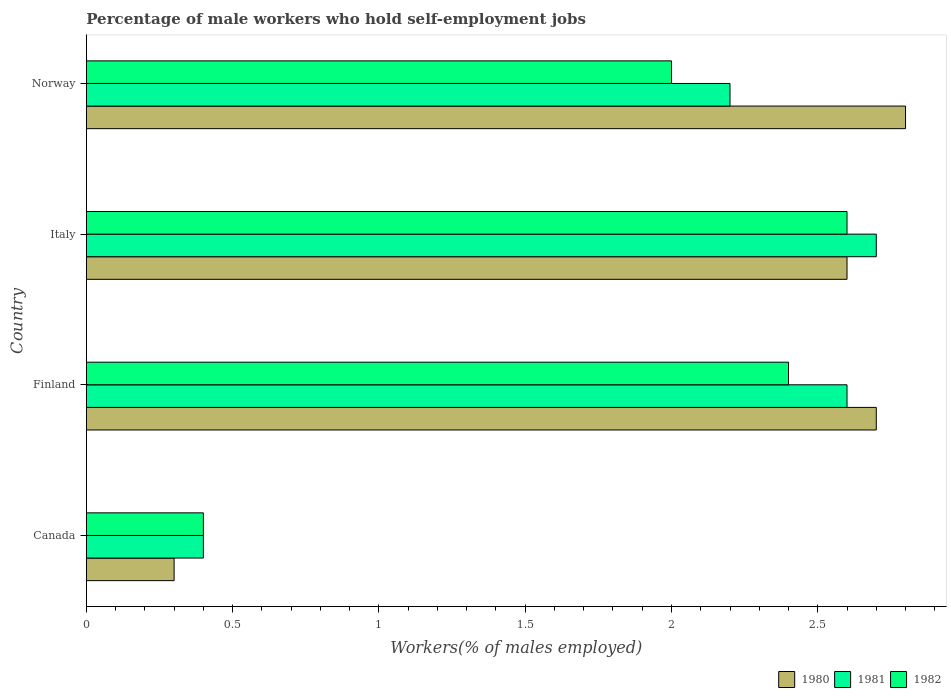Are the number of bars per tick equal to the number of legend labels?
Keep it short and to the point. Yes. Are the number of bars on each tick of the Y-axis equal?
Your answer should be compact. Yes. What is the percentage of self-employed male workers in 1981 in Italy?
Keep it short and to the point. 2.7. Across all countries, what is the maximum percentage of self-employed male workers in 1981?
Offer a very short reply. 2.7. Across all countries, what is the minimum percentage of self-employed male workers in 1982?
Give a very brief answer. 0.4. What is the total percentage of self-employed male workers in 1981 in the graph?
Keep it short and to the point. 7.9. What is the difference between the percentage of self-employed male workers in 1980 in Canada and that in Italy?
Your response must be concise. -2.3. What is the difference between the percentage of self-employed male workers in 1980 in Canada and the percentage of self-employed male workers in 1981 in Finland?
Make the answer very short. -2.3. What is the average percentage of self-employed male workers in 1982 per country?
Ensure brevity in your answer.  1.85. What is the difference between the percentage of self-employed male workers in 1981 and percentage of self-employed male workers in 1982 in Finland?
Offer a very short reply. 0.2. In how many countries, is the percentage of self-employed male workers in 1980 greater than 1.4 %?
Offer a terse response. 3. What is the ratio of the percentage of self-employed male workers in 1982 in Canada to that in Norway?
Provide a succinct answer. 0.2. Is the percentage of self-employed male workers in 1981 in Italy less than that in Norway?
Keep it short and to the point. No. Is the difference between the percentage of self-employed male workers in 1981 in Finland and Italy greater than the difference between the percentage of self-employed male workers in 1982 in Finland and Italy?
Offer a terse response. Yes. What is the difference between the highest and the second highest percentage of self-employed male workers in 1982?
Make the answer very short. 0.2. What is the difference between the highest and the lowest percentage of self-employed male workers in 1982?
Make the answer very short. 2.2. In how many countries, is the percentage of self-employed male workers in 1982 greater than the average percentage of self-employed male workers in 1982 taken over all countries?
Offer a very short reply. 3. What does the 1st bar from the top in Norway represents?
Provide a short and direct response. 1982. What does the 2nd bar from the bottom in Norway represents?
Your answer should be compact. 1981. Is it the case that in every country, the sum of the percentage of self-employed male workers in 1980 and percentage of self-employed male workers in 1982 is greater than the percentage of self-employed male workers in 1981?
Make the answer very short. Yes. How many countries are there in the graph?
Your response must be concise. 4. Does the graph contain grids?
Your answer should be very brief. No. Where does the legend appear in the graph?
Offer a terse response. Bottom right. How many legend labels are there?
Offer a very short reply. 3. What is the title of the graph?
Your answer should be compact. Percentage of male workers who hold self-employment jobs. Does "1993" appear as one of the legend labels in the graph?
Provide a succinct answer. No. What is the label or title of the X-axis?
Your response must be concise. Workers(% of males employed). What is the Workers(% of males employed) in 1980 in Canada?
Your response must be concise. 0.3. What is the Workers(% of males employed) in 1981 in Canada?
Make the answer very short. 0.4. What is the Workers(% of males employed) in 1982 in Canada?
Give a very brief answer. 0.4. What is the Workers(% of males employed) of 1980 in Finland?
Give a very brief answer. 2.7. What is the Workers(% of males employed) of 1981 in Finland?
Ensure brevity in your answer.  2.6. What is the Workers(% of males employed) of 1982 in Finland?
Your answer should be very brief. 2.4. What is the Workers(% of males employed) in 1980 in Italy?
Give a very brief answer. 2.6. What is the Workers(% of males employed) in 1981 in Italy?
Offer a very short reply. 2.7. What is the Workers(% of males employed) in 1982 in Italy?
Offer a very short reply. 2.6. What is the Workers(% of males employed) of 1980 in Norway?
Your answer should be very brief. 2.8. What is the Workers(% of males employed) of 1981 in Norway?
Offer a terse response. 2.2. Across all countries, what is the maximum Workers(% of males employed) of 1980?
Give a very brief answer. 2.8. Across all countries, what is the maximum Workers(% of males employed) in 1981?
Your answer should be compact. 2.7. Across all countries, what is the maximum Workers(% of males employed) of 1982?
Offer a terse response. 2.6. Across all countries, what is the minimum Workers(% of males employed) of 1980?
Keep it short and to the point. 0.3. Across all countries, what is the minimum Workers(% of males employed) of 1981?
Ensure brevity in your answer.  0.4. Across all countries, what is the minimum Workers(% of males employed) of 1982?
Your response must be concise. 0.4. What is the total Workers(% of males employed) in 1980 in the graph?
Your response must be concise. 8.4. What is the total Workers(% of males employed) in 1981 in the graph?
Offer a very short reply. 7.9. What is the total Workers(% of males employed) in 1982 in the graph?
Keep it short and to the point. 7.4. What is the difference between the Workers(% of males employed) of 1980 in Canada and that in Finland?
Offer a terse response. -2.4. What is the difference between the Workers(% of males employed) of 1980 in Canada and that in Norway?
Your response must be concise. -2.5. What is the difference between the Workers(% of males employed) in 1982 in Canada and that in Norway?
Ensure brevity in your answer.  -1.6. What is the difference between the Workers(% of males employed) in 1982 in Finland and that in Norway?
Give a very brief answer. 0.4. What is the difference between the Workers(% of males employed) of 1982 in Italy and that in Norway?
Make the answer very short. 0.6. What is the difference between the Workers(% of males employed) in 1980 in Canada and the Workers(% of males employed) in 1981 in Finland?
Provide a succinct answer. -2.3. What is the difference between the Workers(% of males employed) in 1981 in Canada and the Workers(% of males employed) in 1982 in Finland?
Make the answer very short. -2. What is the difference between the Workers(% of males employed) in 1980 in Canada and the Workers(% of males employed) in 1982 in Italy?
Your response must be concise. -2.3. What is the difference between the Workers(% of males employed) of 1980 in Canada and the Workers(% of males employed) of 1982 in Norway?
Offer a very short reply. -1.7. What is the difference between the Workers(% of males employed) in 1980 in Finland and the Workers(% of males employed) in 1981 in Italy?
Your answer should be very brief. 0. What is the difference between the Workers(% of males employed) in 1980 in Finland and the Workers(% of males employed) in 1982 in Italy?
Your answer should be very brief. 0.1. What is the difference between the Workers(% of males employed) in 1980 in Finland and the Workers(% of males employed) in 1981 in Norway?
Make the answer very short. 0.5. What is the difference between the Workers(% of males employed) in 1980 in Italy and the Workers(% of males employed) in 1982 in Norway?
Keep it short and to the point. 0.6. What is the difference between the Workers(% of males employed) of 1981 in Italy and the Workers(% of males employed) of 1982 in Norway?
Your answer should be very brief. 0.7. What is the average Workers(% of males employed) in 1981 per country?
Ensure brevity in your answer.  1.98. What is the average Workers(% of males employed) of 1982 per country?
Ensure brevity in your answer.  1.85. What is the difference between the Workers(% of males employed) in 1980 and Workers(% of males employed) in 1981 in Canada?
Offer a very short reply. -0.1. What is the difference between the Workers(% of males employed) of 1980 and Workers(% of males employed) of 1982 in Canada?
Make the answer very short. -0.1. What is the difference between the Workers(% of males employed) of 1981 and Workers(% of males employed) of 1982 in Canada?
Keep it short and to the point. 0. What is the difference between the Workers(% of males employed) of 1980 and Workers(% of males employed) of 1981 in Finland?
Offer a very short reply. 0.1. What is the difference between the Workers(% of males employed) in 1981 and Workers(% of males employed) in 1982 in Italy?
Your response must be concise. 0.1. What is the difference between the Workers(% of males employed) in 1980 and Workers(% of males employed) in 1982 in Norway?
Your response must be concise. 0.8. What is the ratio of the Workers(% of males employed) of 1981 in Canada to that in Finland?
Your response must be concise. 0.15. What is the ratio of the Workers(% of males employed) in 1980 in Canada to that in Italy?
Give a very brief answer. 0.12. What is the ratio of the Workers(% of males employed) of 1981 in Canada to that in Italy?
Provide a succinct answer. 0.15. What is the ratio of the Workers(% of males employed) of 1982 in Canada to that in Italy?
Give a very brief answer. 0.15. What is the ratio of the Workers(% of males employed) in 1980 in Canada to that in Norway?
Keep it short and to the point. 0.11. What is the ratio of the Workers(% of males employed) of 1981 in Canada to that in Norway?
Offer a terse response. 0.18. What is the ratio of the Workers(% of males employed) of 1981 in Finland to that in Italy?
Keep it short and to the point. 0.96. What is the ratio of the Workers(% of males employed) of 1982 in Finland to that in Italy?
Offer a terse response. 0.92. What is the ratio of the Workers(% of males employed) in 1980 in Finland to that in Norway?
Your response must be concise. 0.96. What is the ratio of the Workers(% of males employed) in 1981 in Finland to that in Norway?
Give a very brief answer. 1.18. What is the ratio of the Workers(% of males employed) in 1981 in Italy to that in Norway?
Give a very brief answer. 1.23. What is the ratio of the Workers(% of males employed) in 1982 in Italy to that in Norway?
Your answer should be compact. 1.3. What is the difference between the highest and the second highest Workers(% of males employed) of 1980?
Your answer should be compact. 0.1. What is the difference between the highest and the lowest Workers(% of males employed) in 1981?
Your response must be concise. 2.3. 